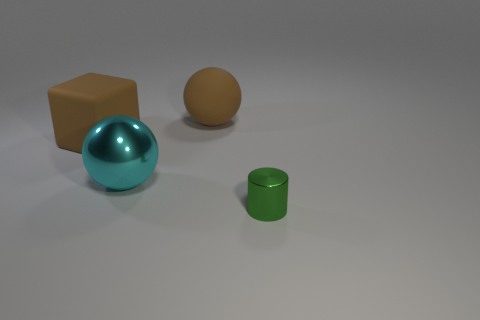Add 4 big spheres. How many objects exist? 8 Subtract 1 cylinders. How many cylinders are left? 0 Subtract all cyan balls. How many balls are left? 1 Subtract all blocks. How many objects are left? 3 Add 2 small green metal objects. How many small green metal objects are left? 3 Add 1 small green cylinders. How many small green cylinders exist? 2 Subtract 1 brown blocks. How many objects are left? 3 Subtract all brown balls. Subtract all yellow cylinders. How many balls are left? 1 Subtract all purple cubes. How many cyan spheres are left? 1 Subtract all metallic balls. Subtract all large spheres. How many objects are left? 1 